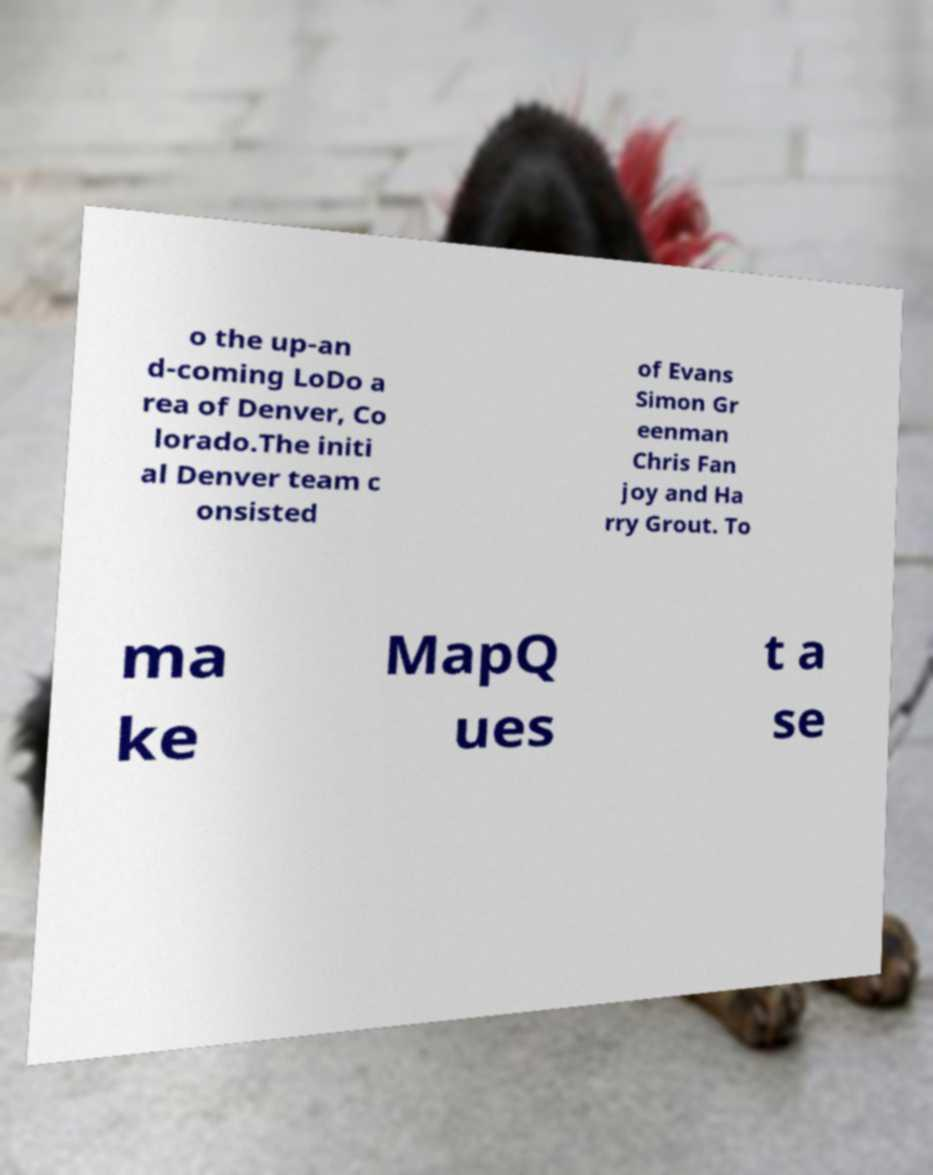Could you extract and type out the text from this image? o the up-an d-coming LoDo a rea of Denver, Co lorado.The initi al Denver team c onsisted of Evans Simon Gr eenman Chris Fan joy and Ha rry Grout. To ma ke MapQ ues t a se 